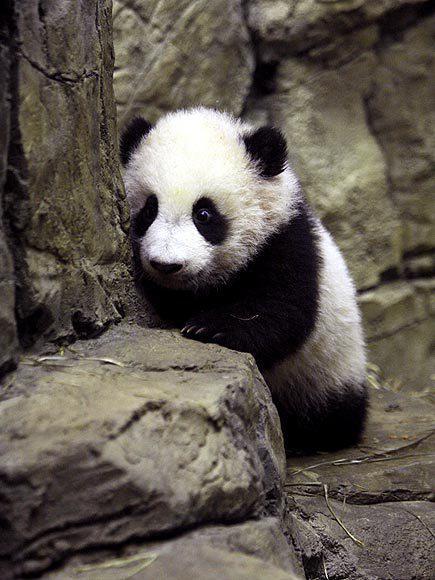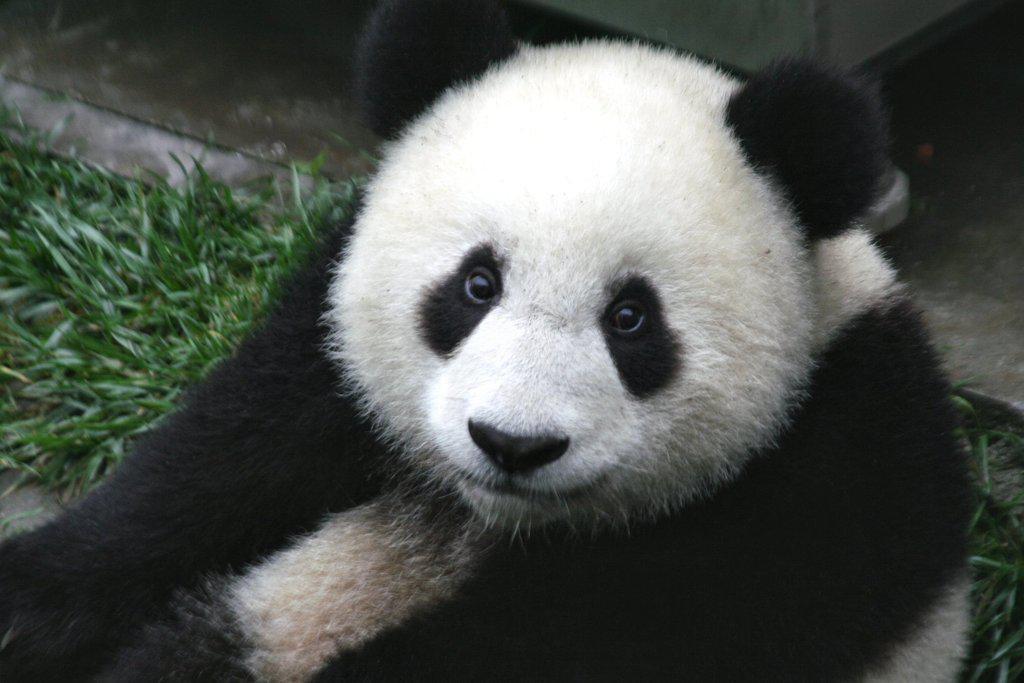The first image is the image on the left, the second image is the image on the right. Given the left and right images, does the statement "An image shows one panda playing with a toy, with its front paws grasping the object." hold true? Answer yes or no. No. The first image is the image on the left, the second image is the image on the right. For the images displayed, is the sentence "One of the images show a single panda holding an object." factually correct? Answer yes or no. No. 